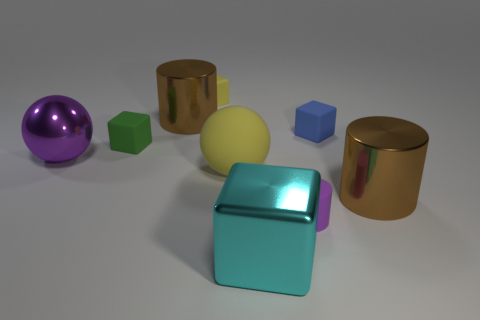Subtract all tiny green blocks. How many blocks are left? 3 Subtract all purple blocks. How many brown cylinders are left? 2 Subtract 1 cubes. How many cubes are left? 3 Subtract all blue cubes. How many cubes are left? 3 Add 1 tiny metallic cylinders. How many objects exist? 10 Subtract all spheres. How many objects are left? 7 Subtract all red cubes. Subtract all purple spheres. How many cubes are left? 4 Subtract all large metal balls. Subtract all cyan metallic cylinders. How many objects are left? 8 Add 5 blue objects. How many blue objects are left? 6 Add 1 large cyan blocks. How many large cyan blocks exist? 2 